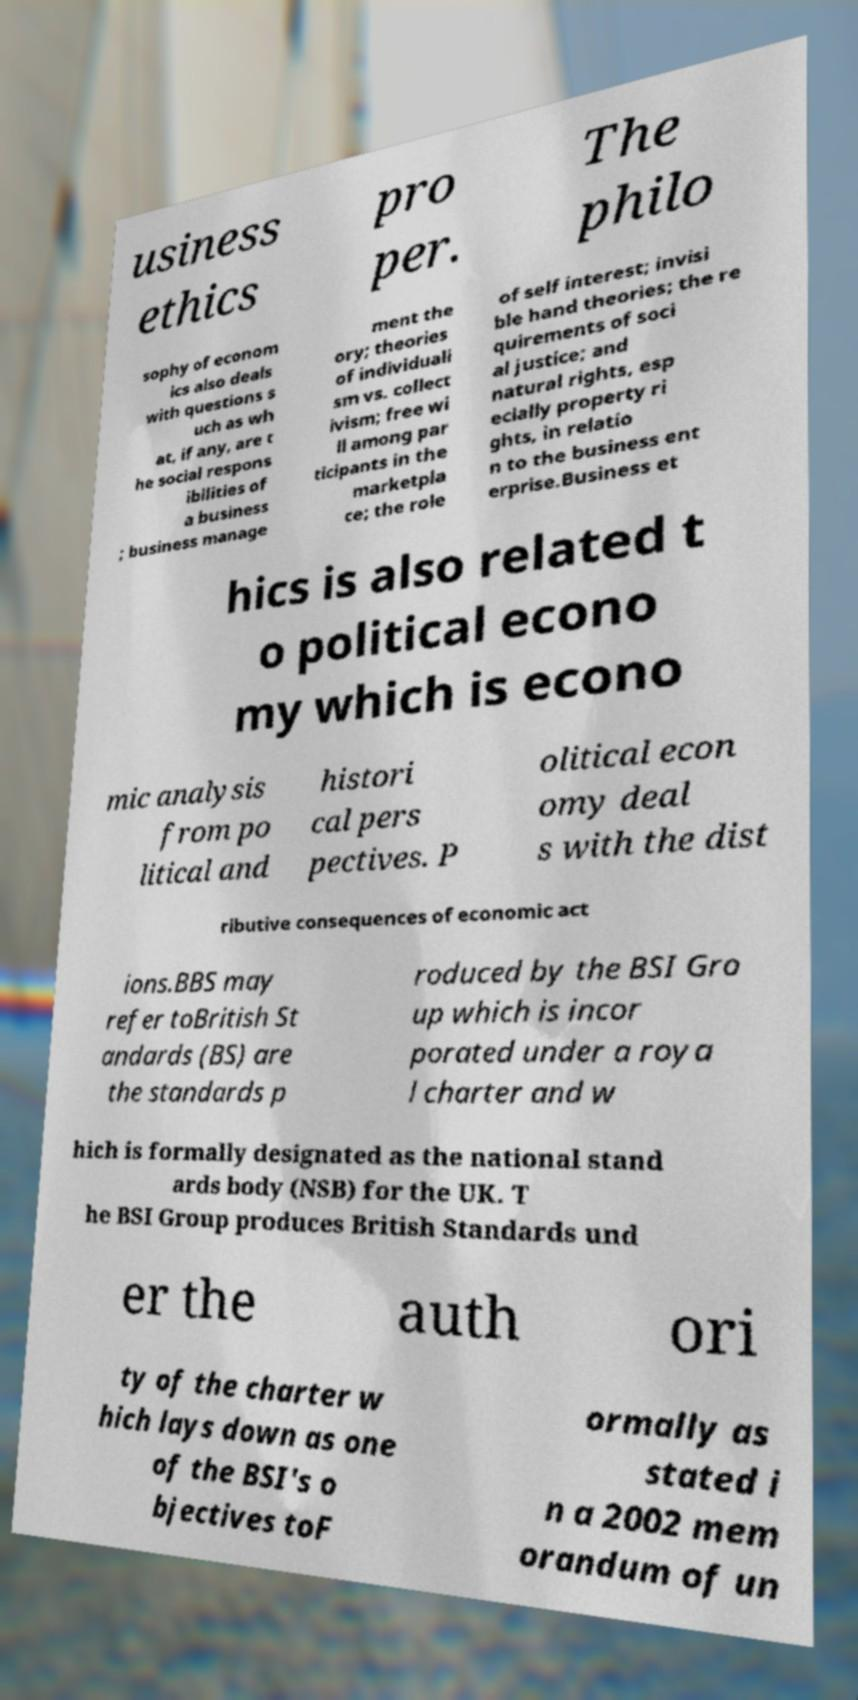Please read and relay the text visible in this image. What does it say? usiness ethics pro per. The philo sophy of econom ics also deals with questions s uch as wh at, if any, are t he social respons ibilities of a business ; business manage ment the ory; theories of individuali sm vs. collect ivism; free wi ll among par ticipants in the marketpla ce; the role of self interest; invisi ble hand theories; the re quirements of soci al justice; and natural rights, esp ecially property ri ghts, in relatio n to the business ent erprise.Business et hics is also related t o political econo my which is econo mic analysis from po litical and histori cal pers pectives. P olitical econ omy deal s with the dist ributive consequences of economic act ions.BBS may refer toBritish St andards (BS) are the standards p roduced by the BSI Gro up which is incor porated under a roya l charter and w hich is formally designated as the national stand ards body (NSB) for the UK. T he BSI Group produces British Standards und er the auth ori ty of the charter w hich lays down as one of the BSI's o bjectives toF ormally as stated i n a 2002 mem orandum of un 